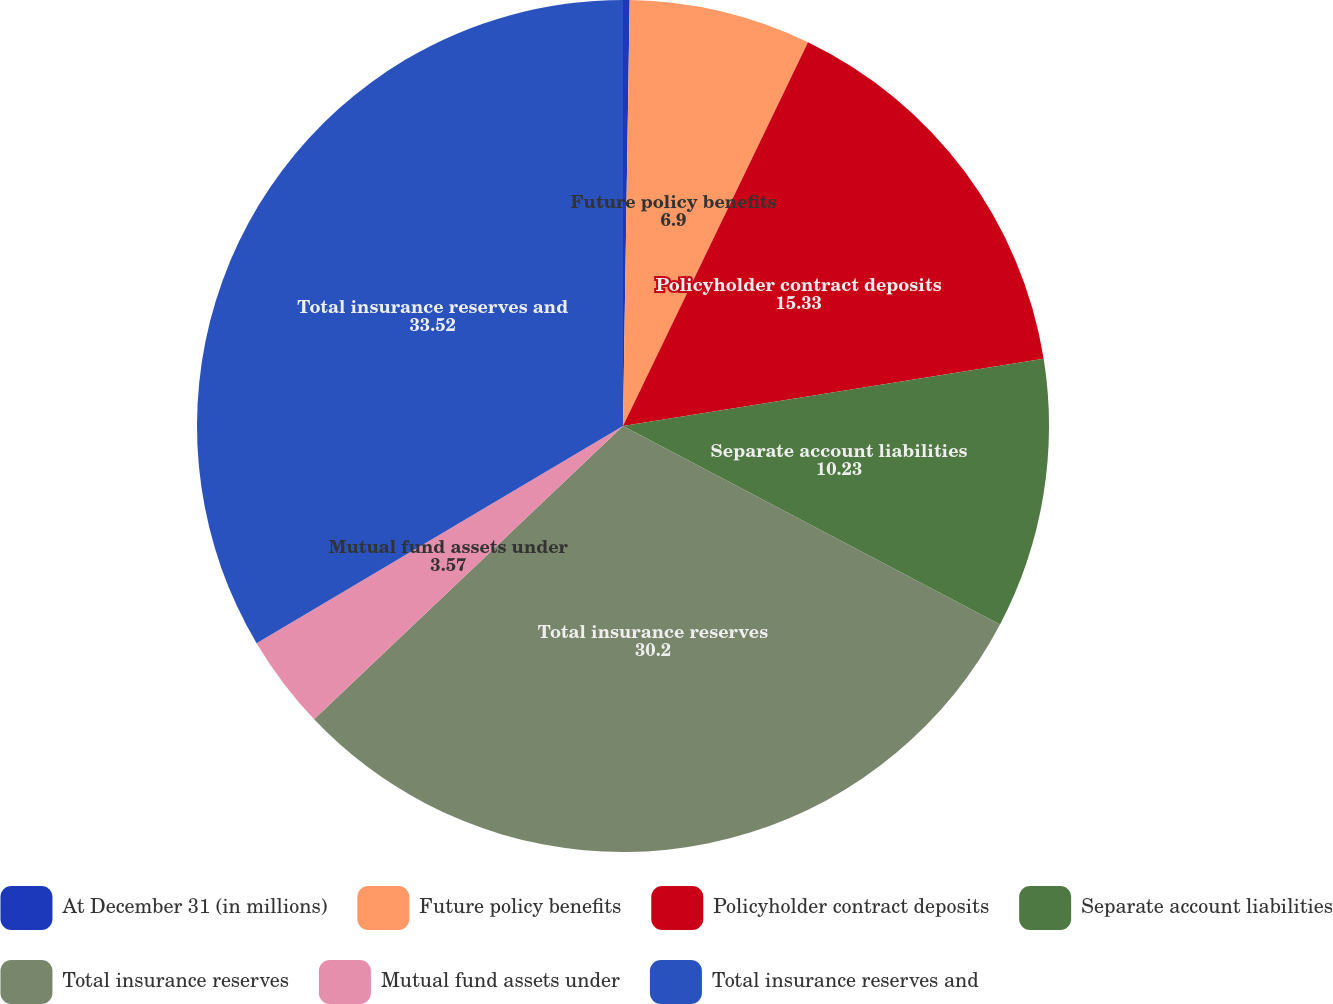<chart> <loc_0><loc_0><loc_500><loc_500><pie_chart><fcel>At December 31 (in millions)<fcel>Future policy benefits<fcel>Policyholder contract deposits<fcel>Separate account liabilities<fcel>Total insurance reserves<fcel>Mutual fund assets under<fcel>Total insurance reserves and<nl><fcel>0.25%<fcel>6.9%<fcel>15.33%<fcel>10.23%<fcel>30.2%<fcel>3.57%<fcel>33.52%<nl></chart> 